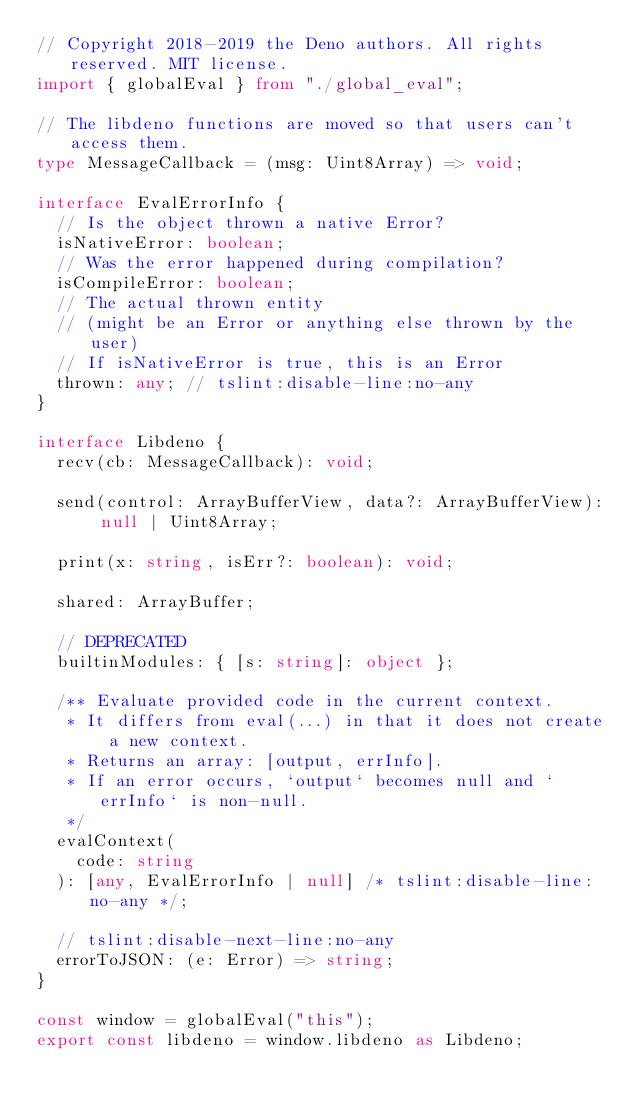Convert code to text. <code><loc_0><loc_0><loc_500><loc_500><_TypeScript_>// Copyright 2018-2019 the Deno authors. All rights reserved. MIT license.
import { globalEval } from "./global_eval";

// The libdeno functions are moved so that users can't access them.
type MessageCallback = (msg: Uint8Array) => void;

interface EvalErrorInfo {
  // Is the object thrown a native Error?
  isNativeError: boolean;
  // Was the error happened during compilation?
  isCompileError: boolean;
  // The actual thrown entity
  // (might be an Error or anything else thrown by the user)
  // If isNativeError is true, this is an Error
  thrown: any; // tslint:disable-line:no-any
}

interface Libdeno {
  recv(cb: MessageCallback): void;

  send(control: ArrayBufferView, data?: ArrayBufferView): null | Uint8Array;

  print(x: string, isErr?: boolean): void;

  shared: ArrayBuffer;

  // DEPRECATED
  builtinModules: { [s: string]: object };

  /** Evaluate provided code in the current context.
   * It differs from eval(...) in that it does not create a new context.
   * Returns an array: [output, errInfo].
   * If an error occurs, `output` becomes null and `errInfo` is non-null.
   */
  evalContext(
    code: string
  ): [any, EvalErrorInfo | null] /* tslint:disable-line:no-any */;

  // tslint:disable-next-line:no-any
  errorToJSON: (e: Error) => string;
}

const window = globalEval("this");
export const libdeno = window.libdeno as Libdeno;
</code> 